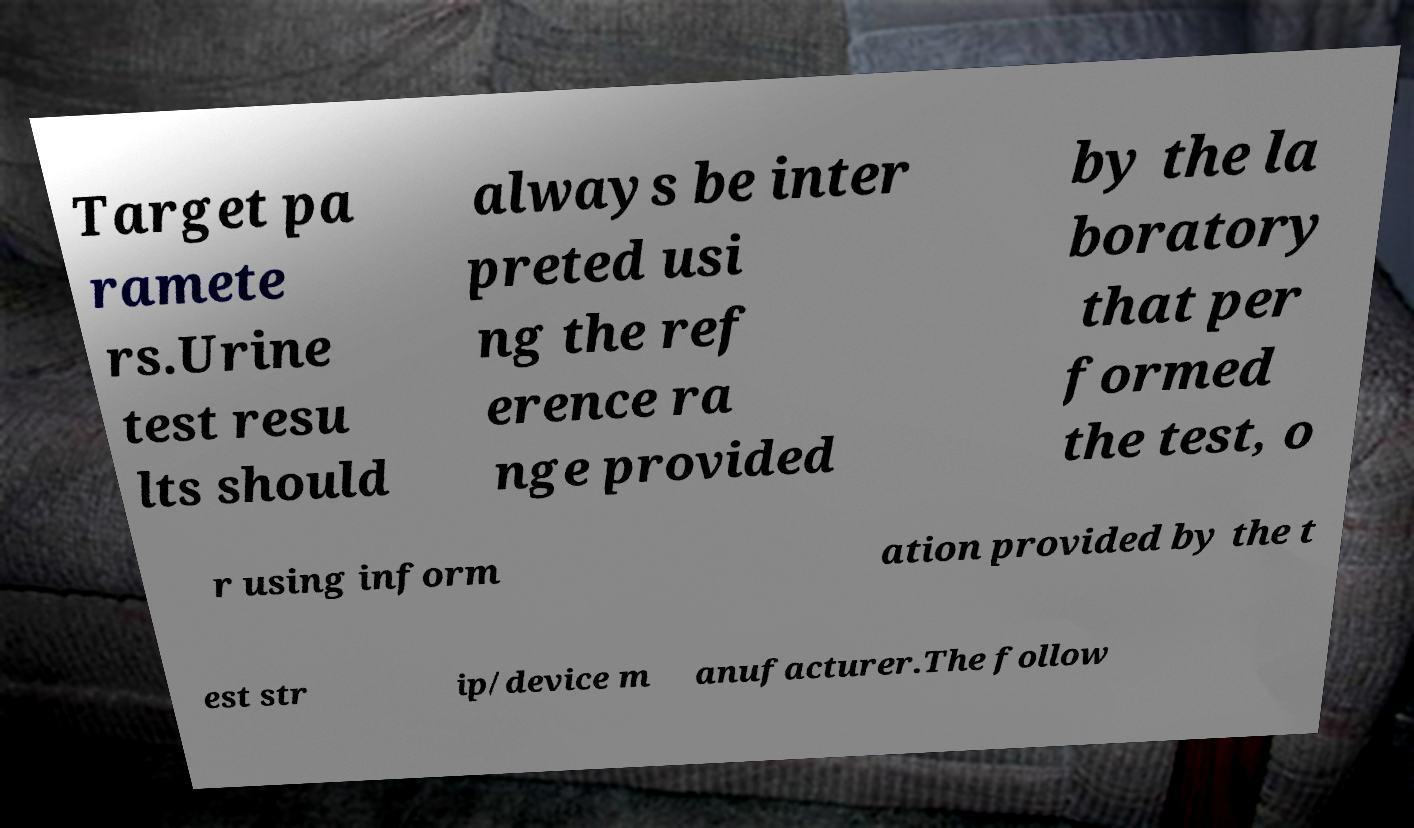Could you extract and type out the text from this image? Target pa ramete rs.Urine test resu lts should always be inter preted usi ng the ref erence ra nge provided by the la boratory that per formed the test, o r using inform ation provided by the t est str ip/device m anufacturer.The follow 